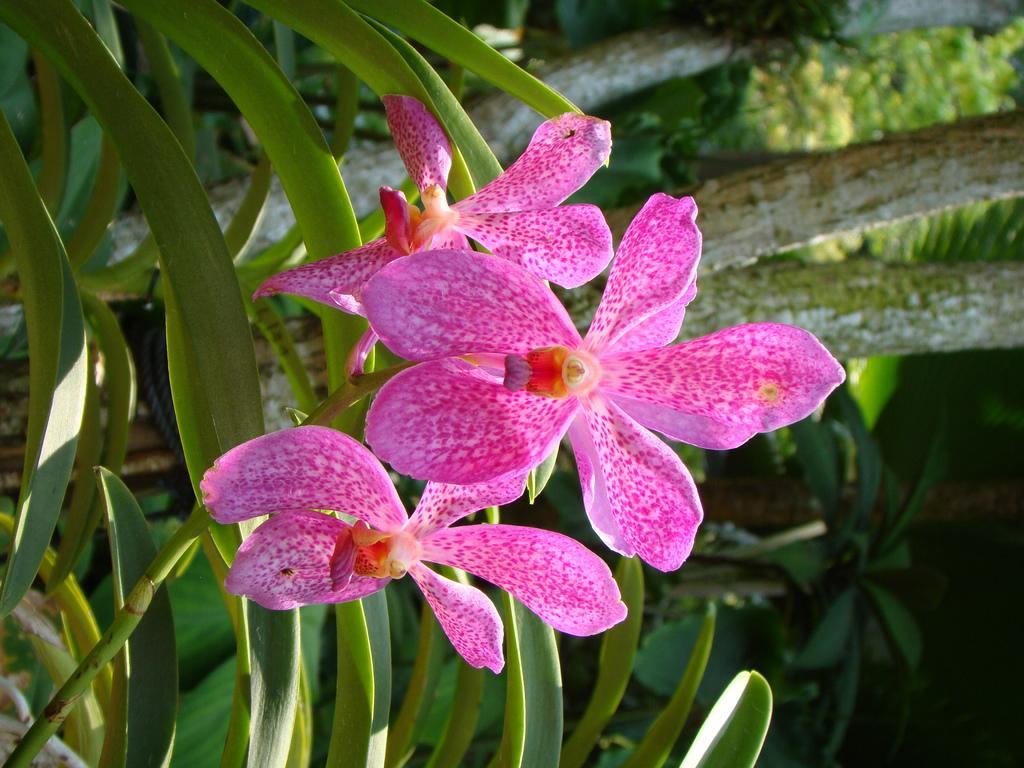In one or two sentences, can you explain what this image depicts? In this image there is a stem having flowers. Behind there are plants having leaves. 